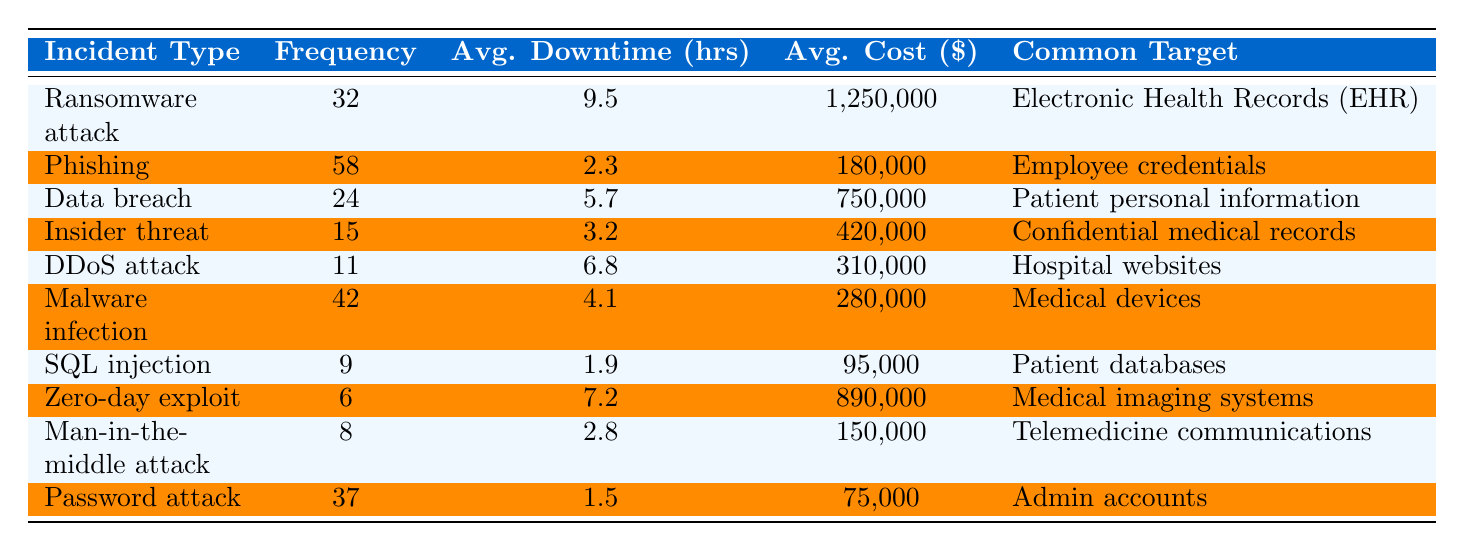What is the most frequent type of cybersecurity incident in healthcare? From the table, we can see that the type of incident with the highest frequency is "Phishing," which has a frequency of 58.
Answer: Phishing How many incidents involved "Ransomware attacks"? According to the table, the frequency of "Ransomware attack" incidents is 32, as listed.
Answer: 32 What is the average downtime for Data breaches? The table indicates that the average downtime for "Data breach" incidents is 5.7 hours, as shown in that row.
Answer: 5.7 hours What is the average cost associated with "Malware infections"? Referring to the table, the average cost for "Malware infection" incidents is $280,000, which is provided in its row.
Answer: $280,000 How many cybersecurity incidents have a frequency of less than 10? By looking at the table, we find "SQL injection" (9 incidents) and "Zero-day exploit" (6 incidents) for a total of 2 incidents with a frequency less than 10.
Answer: 2 What is the common target for "Insider threat" incidents? The table specifies that the common target for "Insider threat" is "Confidential medical records," as reflected in that row of data.
Answer: Confidential medical records If we add the costs of all incidents listed, what would be the total? The total cost is calculated as follows: (1,250,000 + 180,000 + 750,000 + 420,000 + 310,000 + 280,000 + 95,000 + 890,000 + 150,000 + 75,000) = 3,360,000. This is the sum of the average costs column.
Answer: $3,360,000 Which incident type has the longest average downtime? From the table, "Ransomware attack" has the longest average downtime of 9.5 hours, which stands out when compared to other incident types.
Answer: Ransomware attack Is the average downtime for "Phishing" incidents greater than 2 hours? The table states that the average downtime for "Phishing" incidents is 2.3 hours, which indeed is greater than 2 hours.
Answer: Yes What is the difference in average cost between "Data breach" and "Malware infection"? The average cost for "Data breach" is $750,000 and for "Malware infection" it is $280,000. The difference is $750,000 - $280,000 = $470,000.
Answer: $470,000 